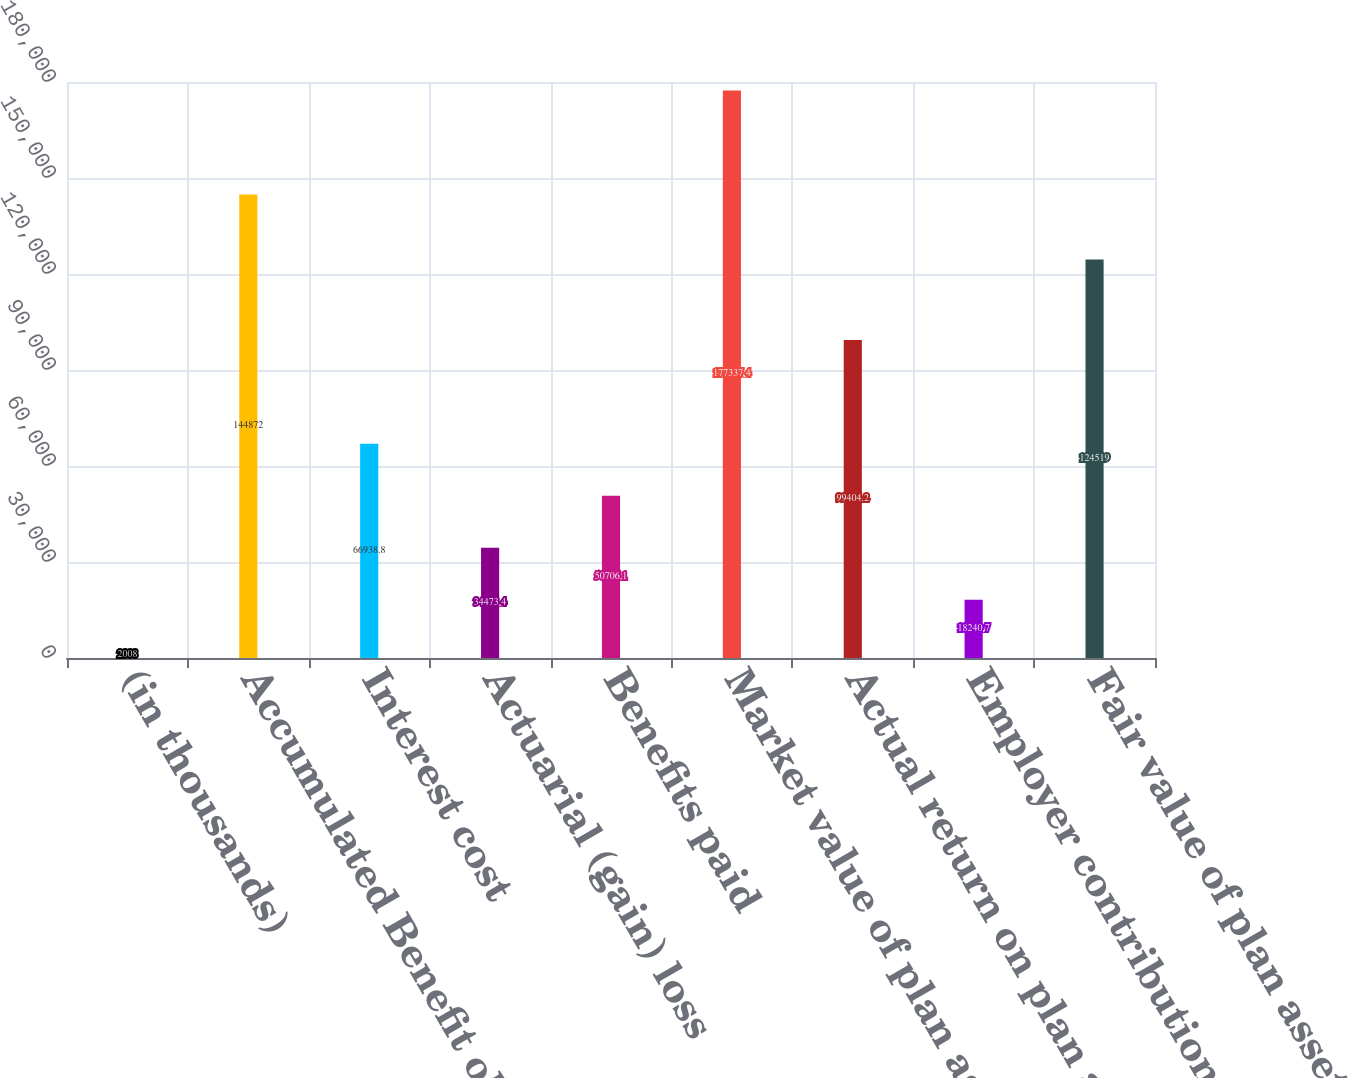<chart> <loc_0><loc_0><loc_500><loc_500><bar_chart><fcel>(in thousands)<fcel>Accumulated Benefit obligation<fcel>Interest cost<fcel>Actuarial (gain) loss<fcel>Benefits paid<fcel>Market value of plan assets at<fcel>Actual return on plan assets<fcel>Employer contribution<fcel>Fair value of plan assets at<nl><fcel>2008<fcel>144872<fcel>66938.8<fcel>34473.4<fcel>50706.1<fcel>177337<fcel>99404.2<fcel>18240.7<fcel>124519<nl></chart> 